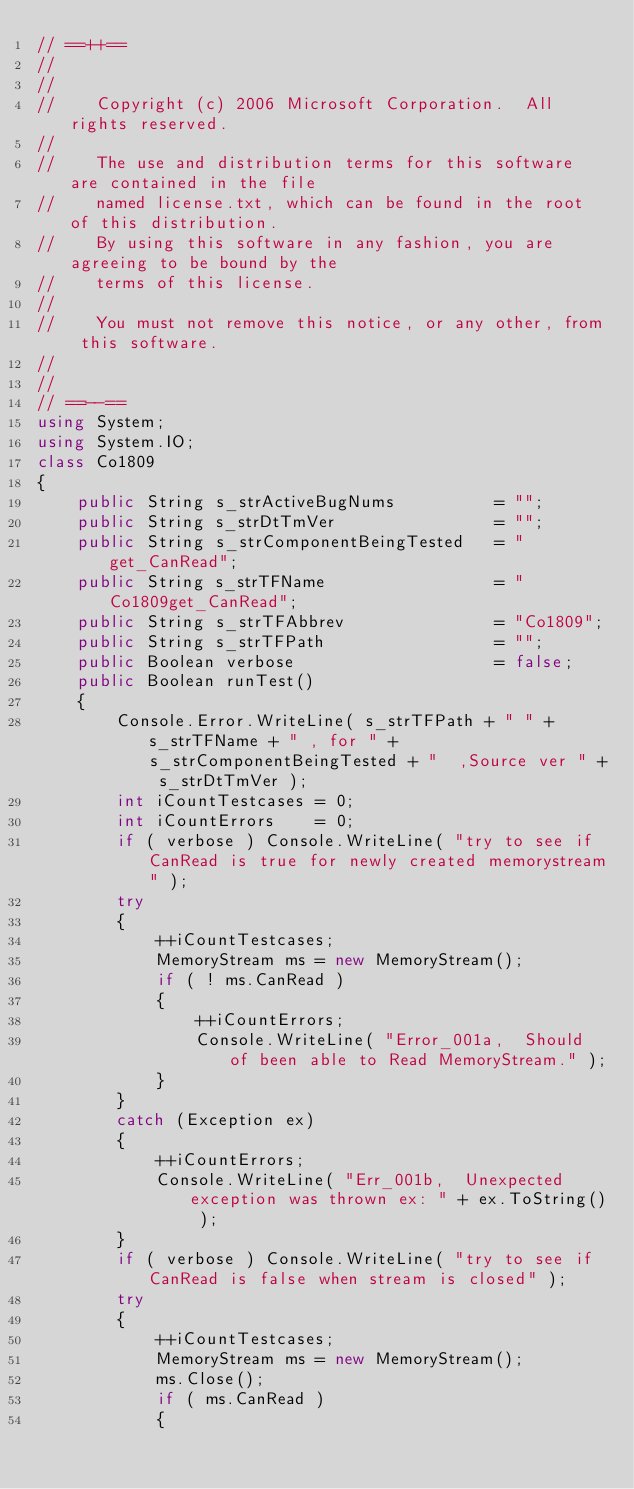Convert code to text. <code><loc_0><loc_0><loc_500><loc_500><_C#_>// ==++==
//
//   
//    Copyright (c) 2006 Microsoft Corporation.  All rights reserved.
//   
//    The use and distribution terms for this software are contained in the file
//    named license.txt, which can be found in the root of this distribution.
//    By using this software in any fashion, you are agreeing to be bound by the
//    terms of this license.
//   
//    You must not remove this notice, or any other, from this software.
//   
//
// ==--==
using System;
using System.IO;
class Co1809
{
    public String s_strActiveBugNums          = "";
    public String s_strDtTmVer                = "";
    public String s_strComponentBeingTested   = "get_CanRead";
    public String s_strTFName                 = "Co1809get_CanRead";
    public String s_strTFAbbrev               = "Co1809";
    public String s_strTFPath                 = "";
    public Boolean verbose                    = false;
    public Boolean runTest()
    {
        Console.Error.WriteLine( s_strTFPath + " " + s_strTFName + " , for " + s_strComponentBeingTested + "  ,Source ver " + s_strDtTmVer );
        int iCountTestcases = 0;
        int iCountErrors    = 0;
        if ( verbose ) Console.WriteLine( "try to see if CanRead is true for newly created memorystream" );
        try
        {
            ++iCountTestcases;
            MemoryStream ms = new MemoryStream();
            if ( ! ms.CanRead )
            {
                ++iCountErrors;
                Console.WriteLine( "Error_001a,  Should of been able to Read MemoryStream." );
            }
        }
        catch (Exception ex)
        {
            ++iCountErrors;
            Console.WriteLine( "Err_001b,  Unexpected exception was thrown ex: " + ex.ToString() );
        }
        if ( verbose ) Console.WriteLine( "try to see if CanRead is false when stream is closed" );
        try
        {
            ++iCountTestcases;
            MemoryStream ms = new MemoryStream();
            ms.Close();
            if ( ms.CanRead )
            {</code> 